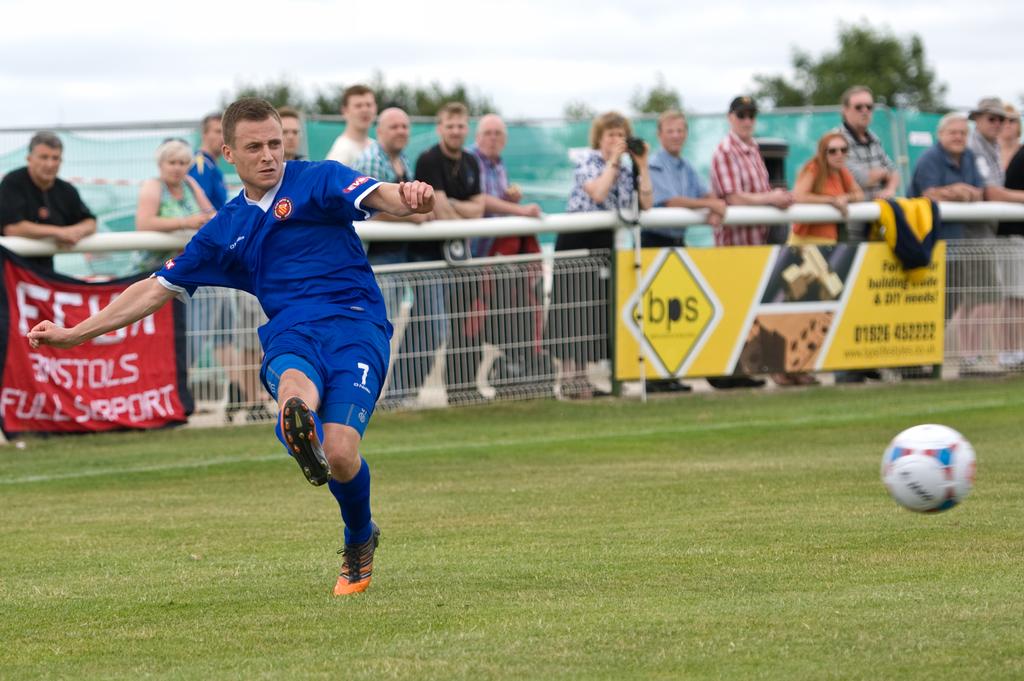What number is on her shorts?
Provide a short and direct response. 7. 